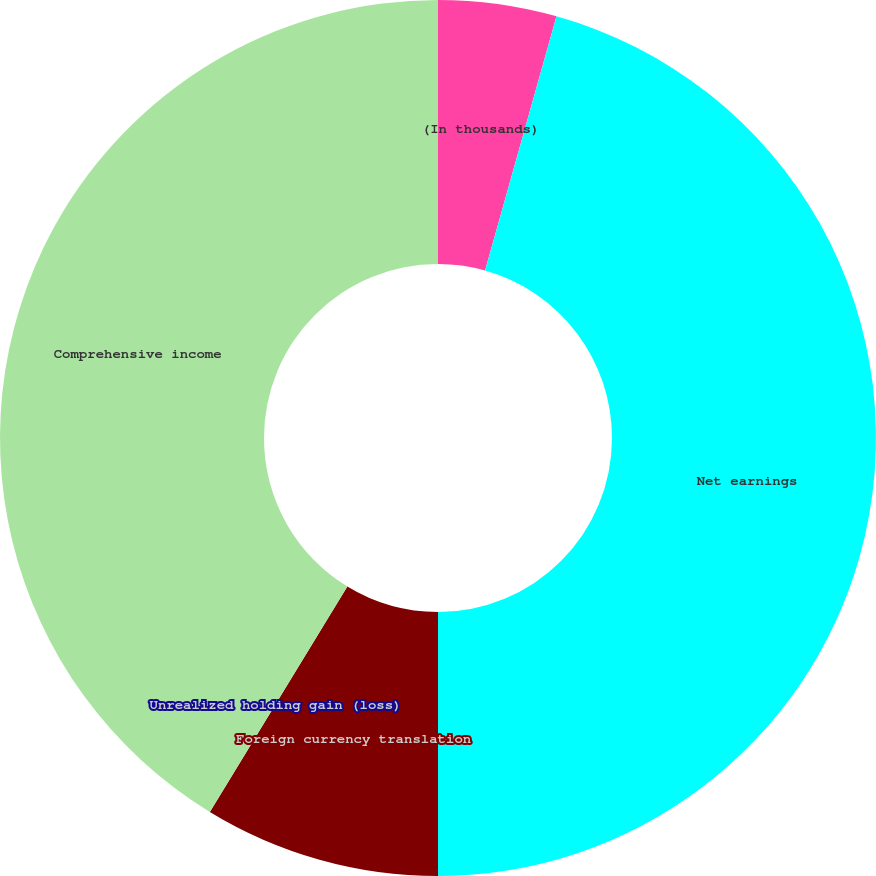Convert chart. <chart><loc_0><loc_0><loc_500><loc_500><pie_chart><fcel>(In thousands)<fcel>Net earnings<fcel>Foreign currency translation<fcel>Unrealized holding gain (loss)<fcel>Comprehensive income<nl><fcel>4.36%<fcel>45.64%<fcel>8.72%<fcel>0.0%<fcel>41.28%<nl></chart> 